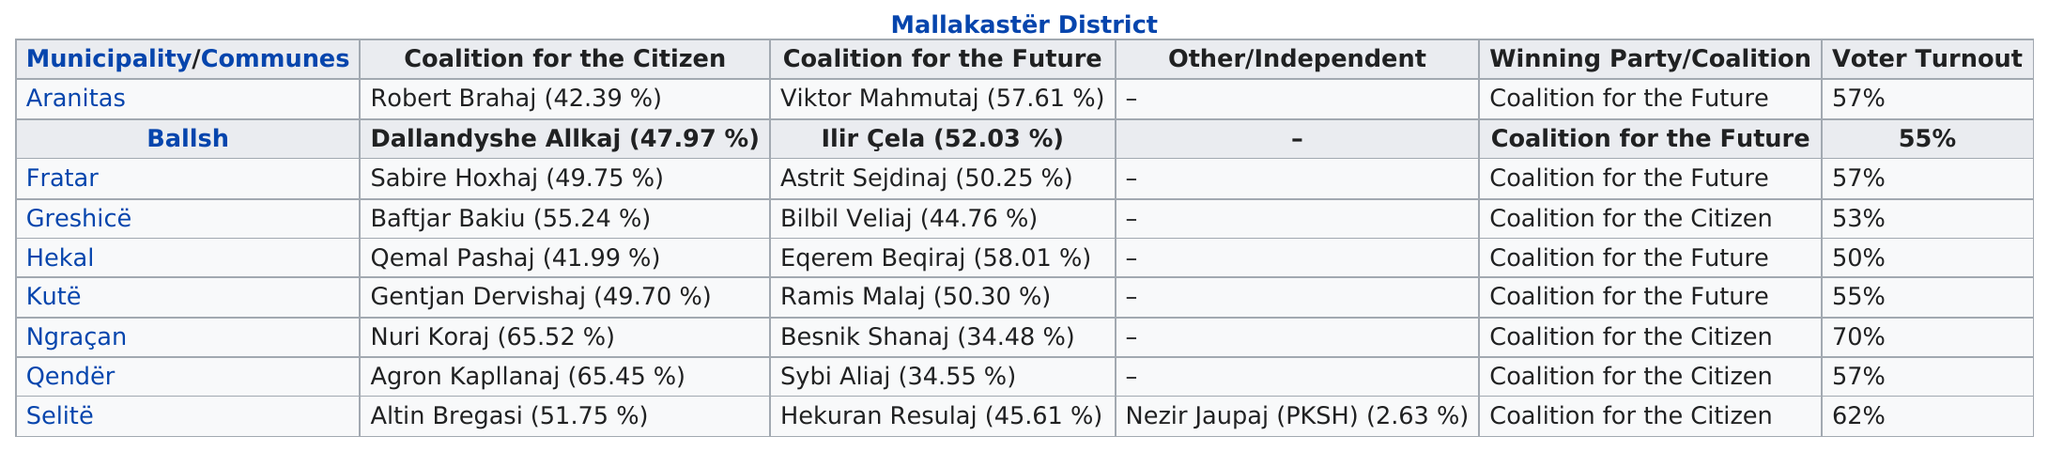Outline some significant characteristics in this image. In the Fratar municipality, the difference in votes between Savire Hoxhaj and Astrit Sejdinaj was only 0.5%. The voter turnout percentage for the festival was 57%. The municipality with the highest voter turnout is Ngraçan. The difference between the percentages of votes between allkaji and cela is 4.06%. Coalition for the Future won 5 seats in the election. 